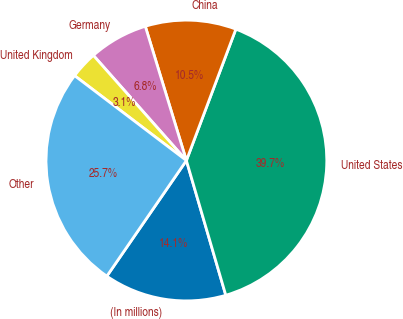Convert chart. <chart><loc_0><loc_0><loc_500><loc_500><pie_chart><fcel>(In millions)<fcel>United States<fcel>China<fcel>Germany<fcel>United Kingdom<fcel>Other<nl><fcel>14.12%<fcel>39.74%<fcel>10.46%<fcel>6.8%<fcel>3.14%<fcel>25.74%<nl></chart> 